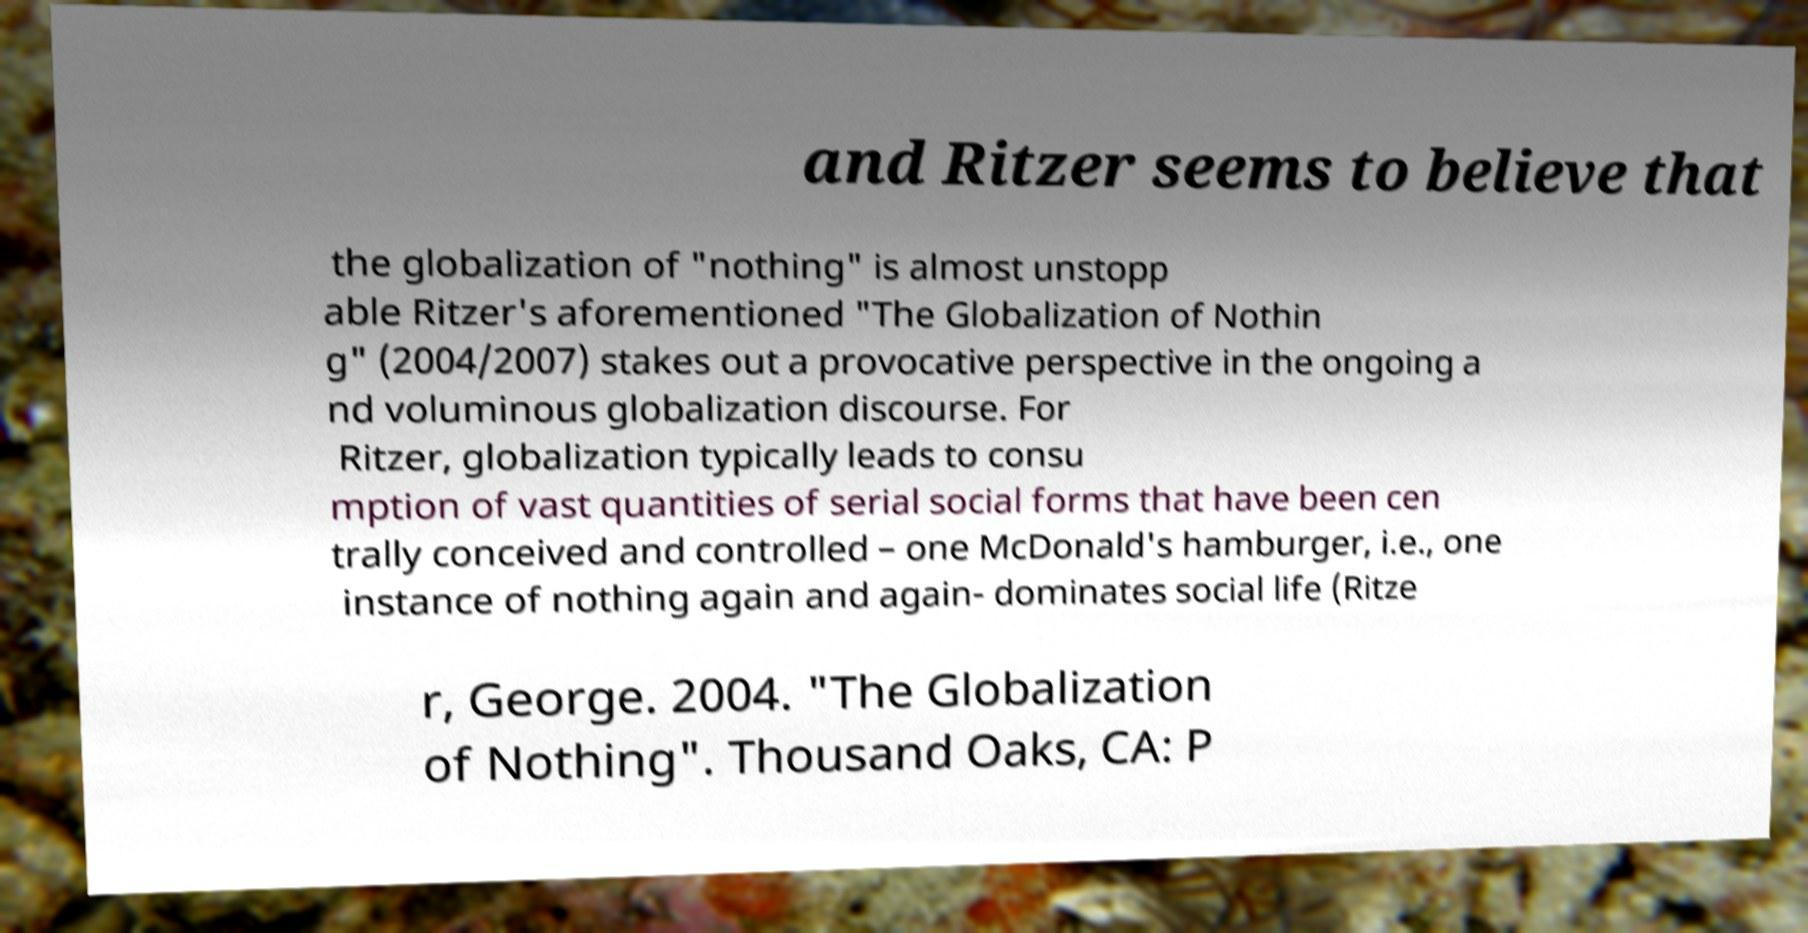There's text embedded in this image that I need extracted. Can you transcribe it verbatim? and Ritzer seems to believe that the globalization of "nothing" is almost unstopp able Ritzer's aforementioned "The Globalization of Nothin g" (2004/2007) stakes out a provocative perspective in the ongoing a nd voluminous globalization discourse. For Ritzer, globalization typically leads to consu mption of vast quantities of serial social forms that have been cen trally conceived and controlled – one McDonald's hamburger, i.e., one instance of nothing again and again- dominates social life (Ritze r, George. 2004. "The Globalization of Nothing". Thousand Oaks, CA: P 